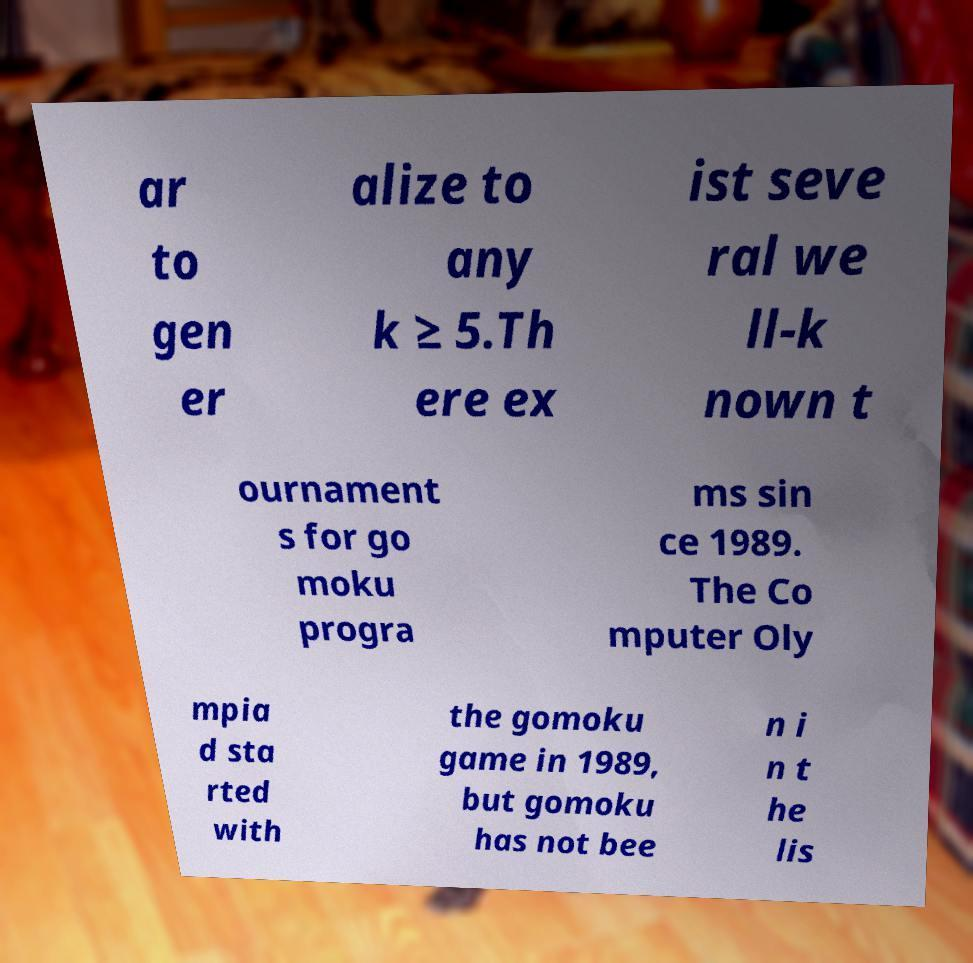Can you accurately transcribe the text from the provided image for me? ar to gen er alize to any k ≥ 5.Th ere ex ist seve ral we ll-k nown t ournament s for go moku progra ms sin ce 1989. The Co mputer Oly mpia d sta rted with the gomoku game in 1989, but gomoku has not bee n i n t he lis 